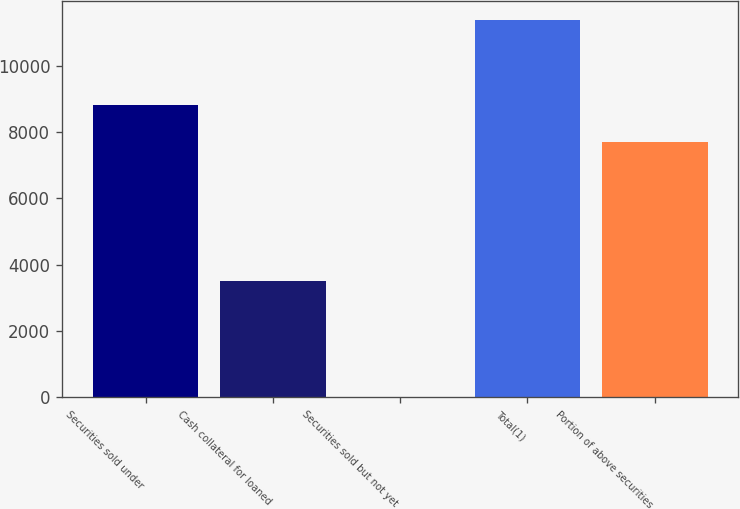Convert chart to OTSL. <chart><loc_0><loc_0><loc_500><loc_500><bar_chart><fcel>Securities sold under<fcel>Cash collateral for loaned<fcel>Securities sold but not yet<fcel>Total(1)<fcel>Portion of above securities<nl><fcel>8828.8<fcel>3496<fcel>2<fcel>11380<fcel>7691<nl></chart> 